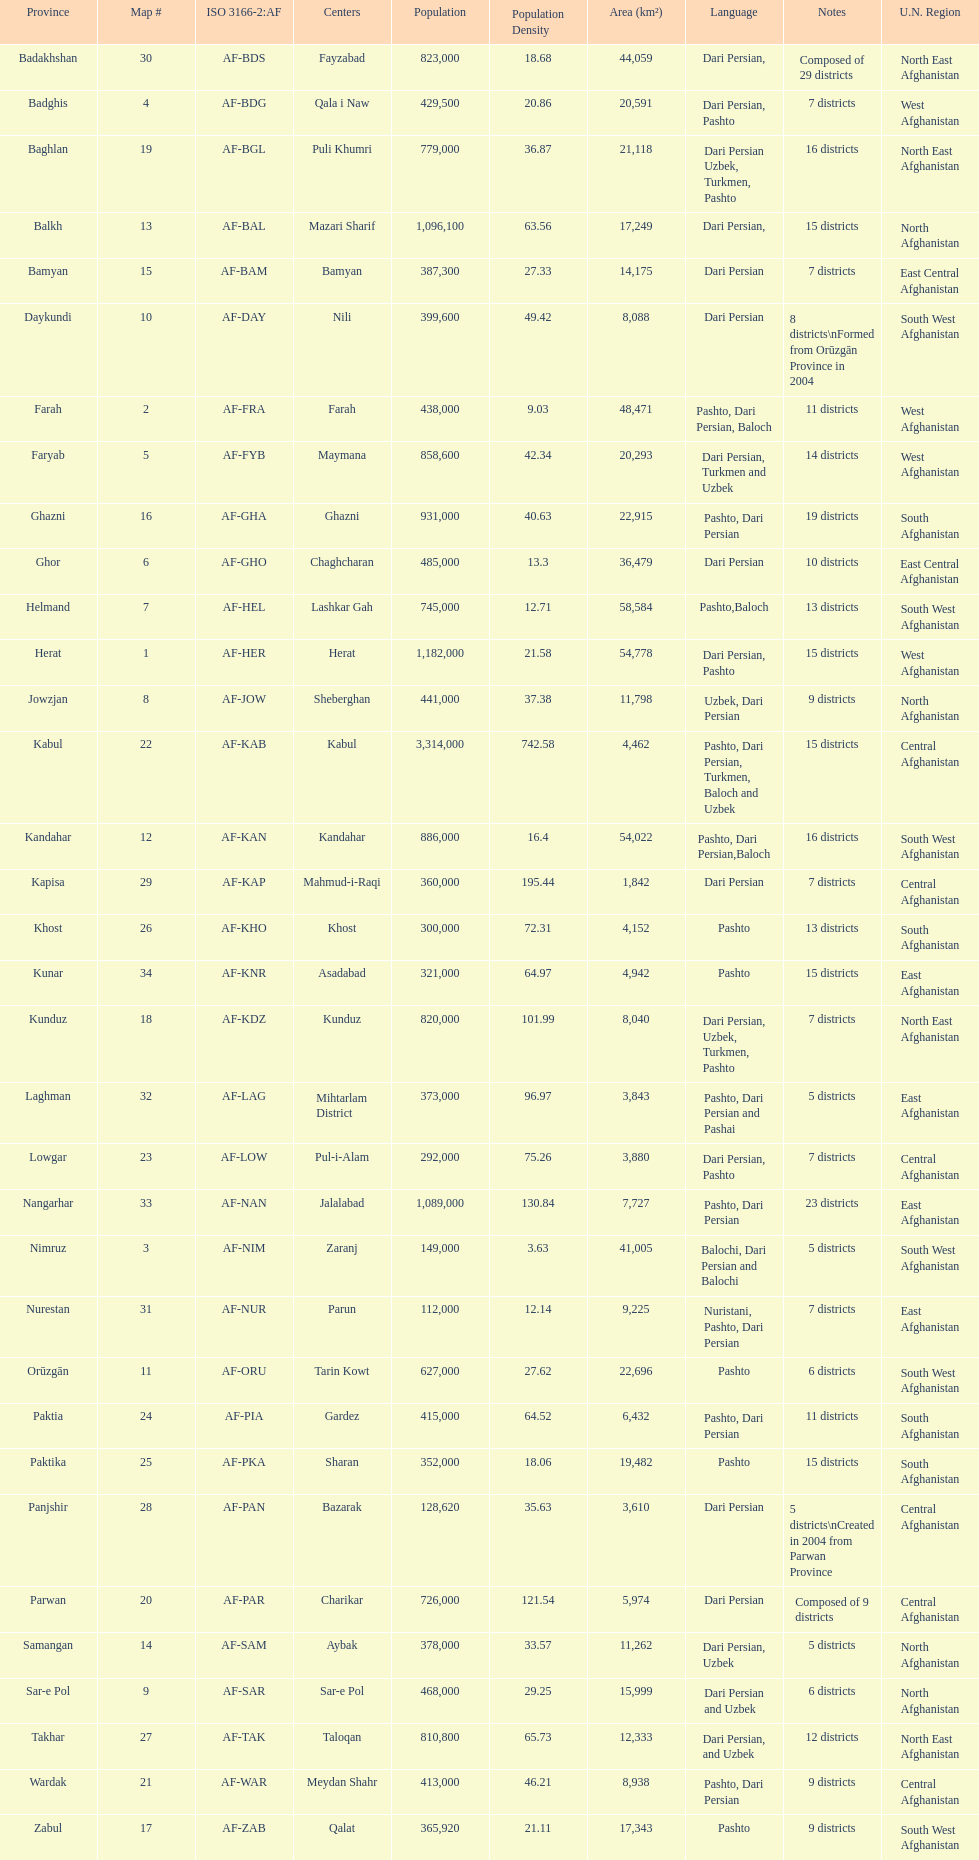Which region is mentioned before ghor? Ghazni. 